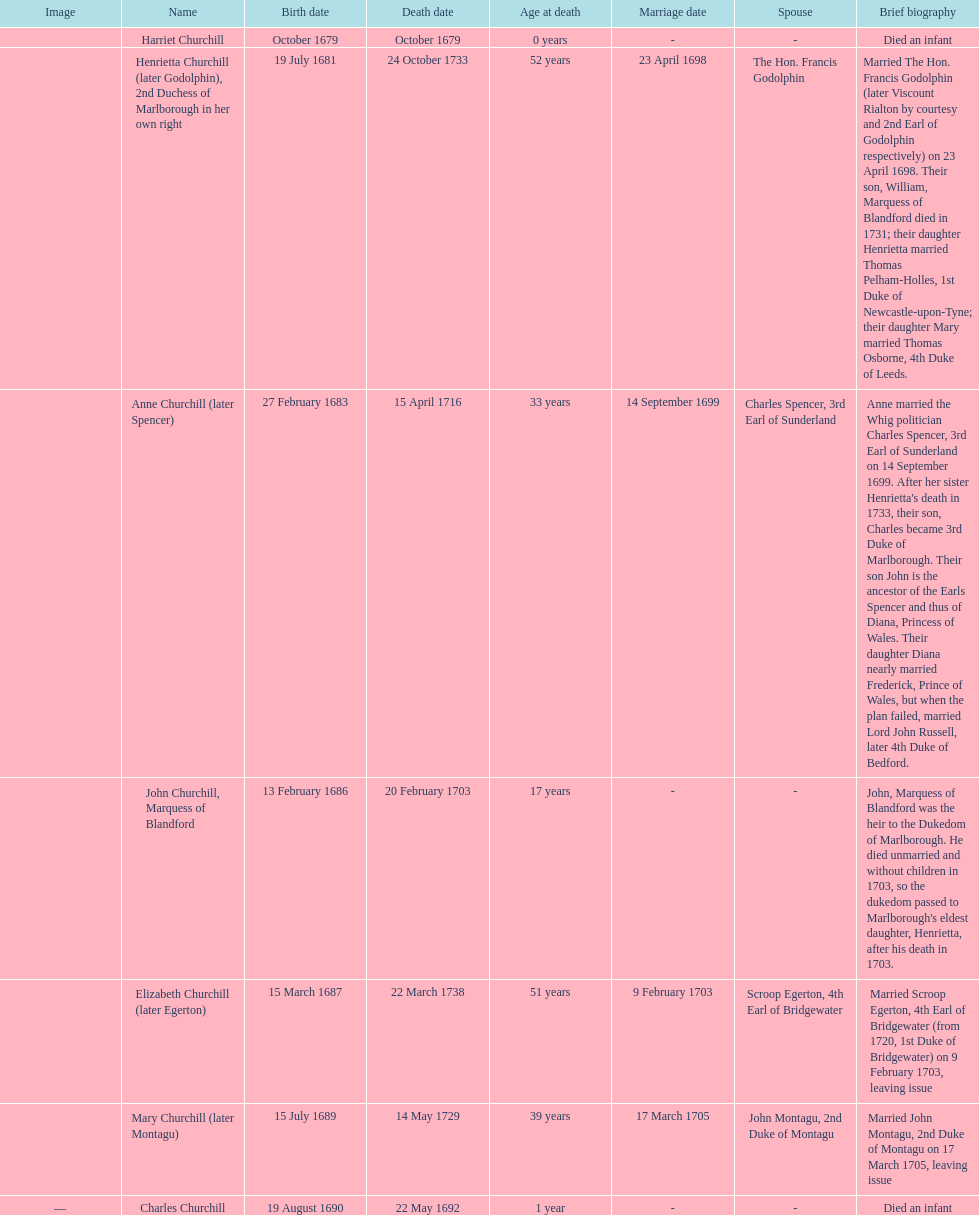Which child was born after elizabeth churchill? Mary Churchill. 